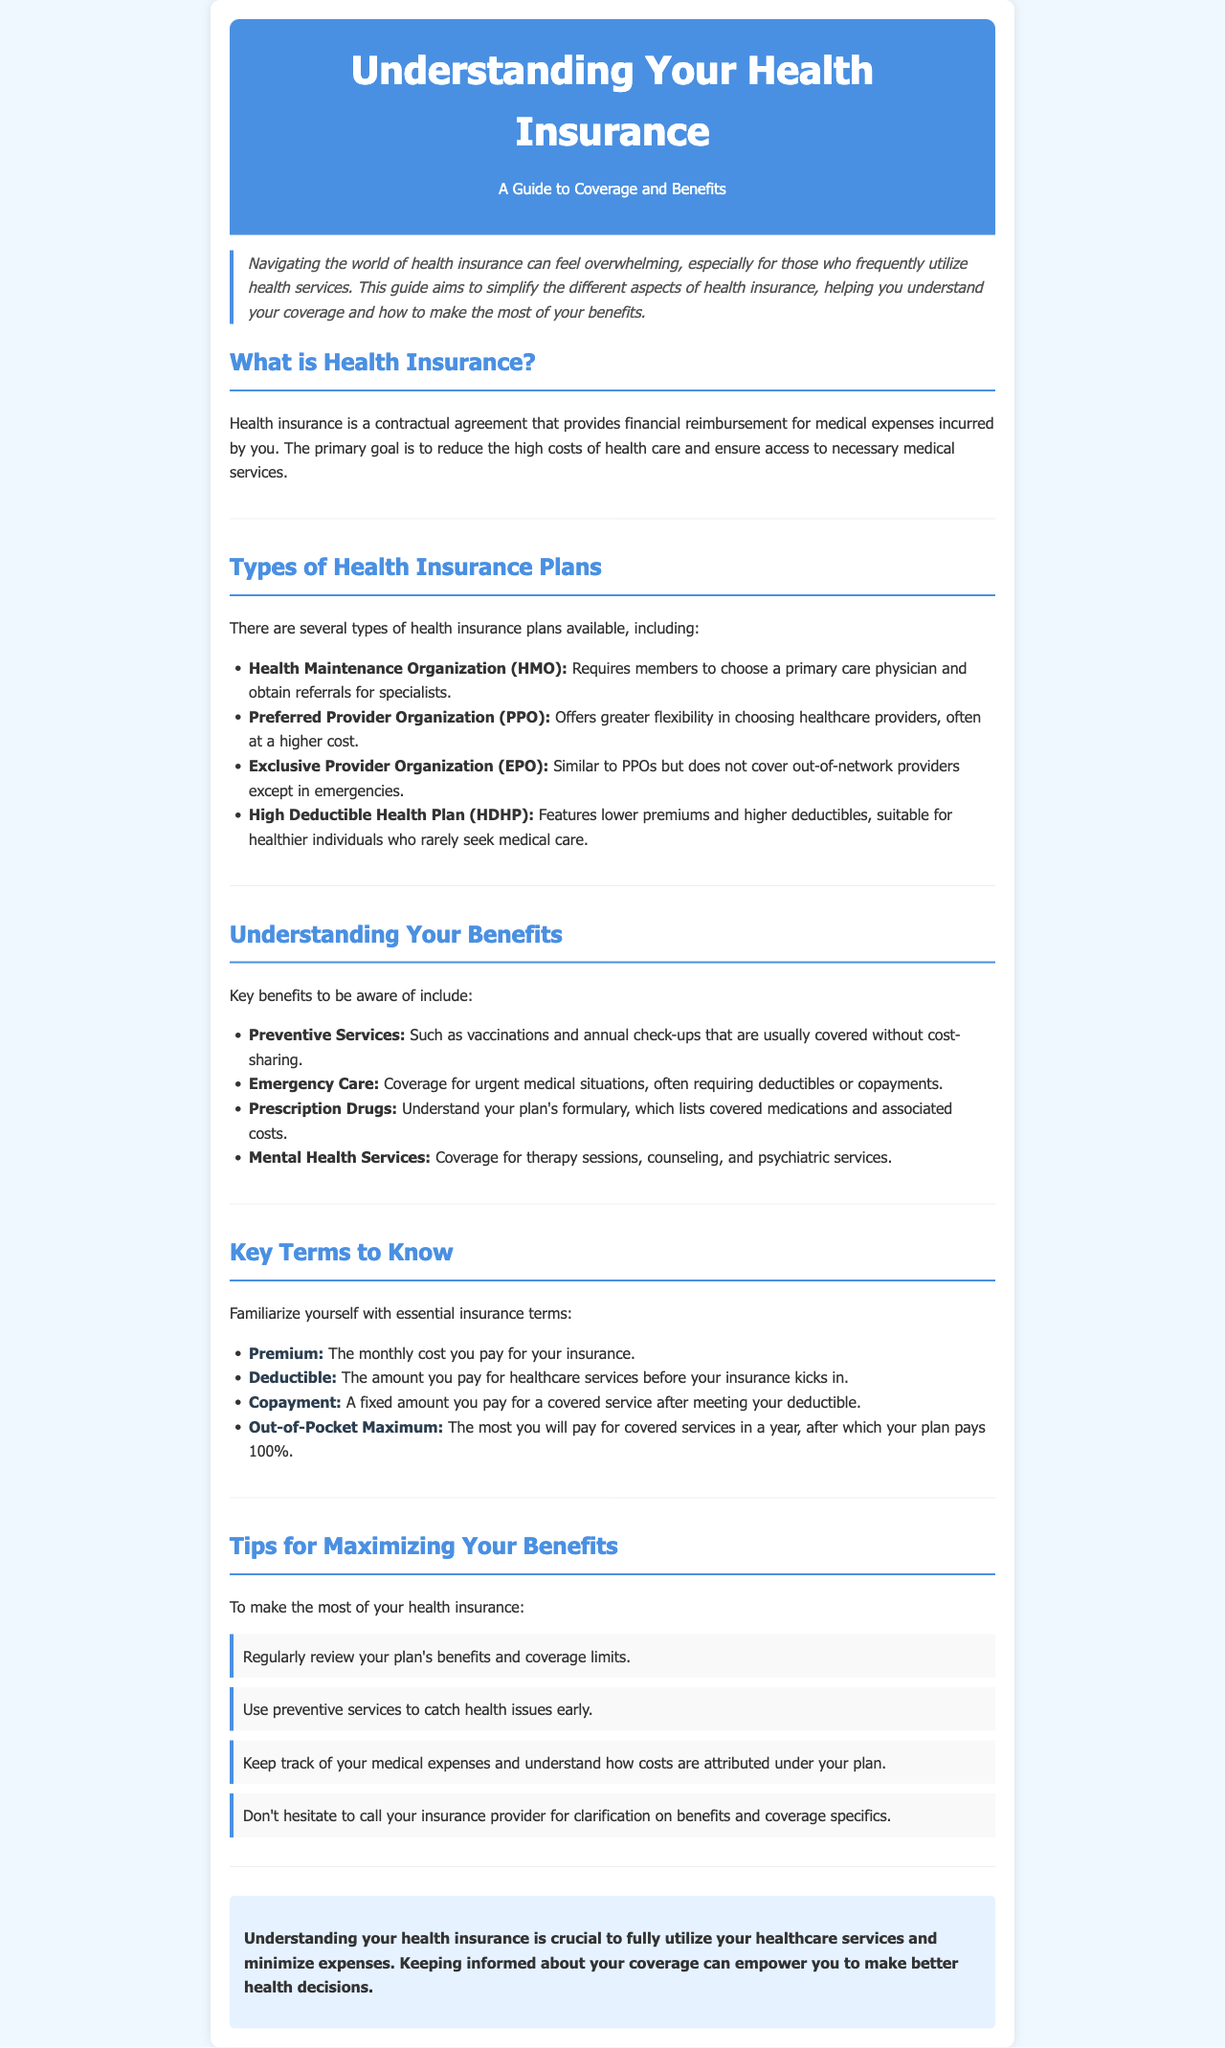What is the primary goal of health insurance? The primary goal is to reduce the high costs of health care and ensure access to necessary medical services.
Answer: To reduce high costs and ensure access What type of health insurance plan requires referrals for specialists? An HMO requires members to choose a primary care physician and obtain referrals for specialists.
Answer: HMO What is covered without cost-sharing? Preventive services such as vaccinations and annual check-ups are usually covered without cost-sharing.
Answer: Preventive services What is the fixed amount you pay for a covered service after meeting your deductible called? It is called a copayment.
Answer: Copayment What should you regularly review to make the most of your health insurance? You should regularly review your plan's benefits and coverage limits.
Answer: Your plan's benefits How many types of health insurance plans are mentioned in the document? There are four types of health insurance plans mentioned in the document.
Answer: Four What is the maximum you will pay for covered services in a year called? The most you will pay is called the out-of-pocket maximum.
Answer: Out-of-pocket maximum What are you encouraged to do if you are unclear about your benefits? You are encouraged to call your insurance provider for clarification on benefits.
Answer: Call your insurance provider 